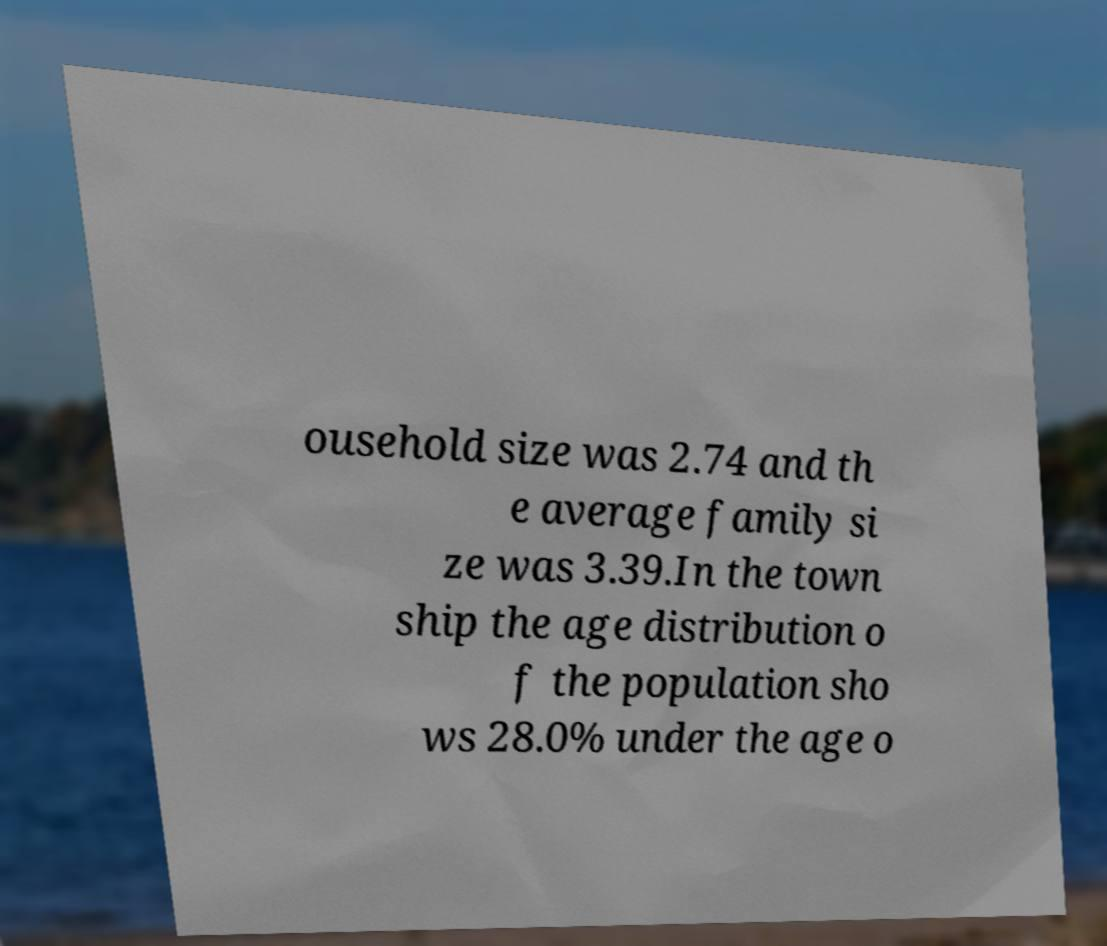Can you read and provide the text displayed in the image?This photo seems to have some interesting text. Can you extract and type it out for me? ousehold size was 2.74 and th e average family si ze was 3.39.In the town ship the age distribution o f the population sho ws 28.0% under the age o 